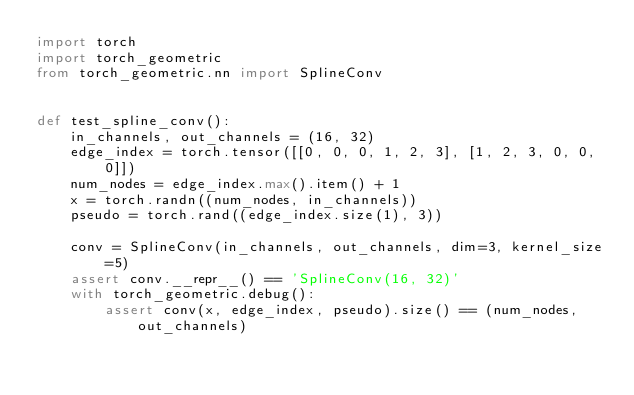Convert code to text. <code><loc_0><loc_0><loc_500><loc_500><_Python_>import torch
import torch_geometric
from torch_geometric.nn import SplineConv


def test_spline_conv():
    in_channels, out_channels = (16, 32)
    edge_index = torch.tensor([[0, 0, 0, 1, 2, 3], [1, 2, 3, 0, 0, 0]])
    num_nodes = edge_index.max().item() + 1
    x = torch.randn((num_nodes, in_channels))
    pseudo = torch.rand((edge_index.size(1), 3))

    conv = SplineConv(in_channels, out_channels, dim=3, kernel_size=5)
    assert conv.__repr__() == 'SplineConv(16, 32)'
    with torch_geometric.debug():
        assert conv(x, edge_index, pseudo).size() == (num_nodes, out_channels)
</code> 